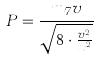Convert formula to latex. <formula><loc_0><loc_0><loc_500><loc_500>P = \frac { m _ { 7 } v } { \sqrt { 8 \cdot \frac { v ^ { 2 } } { x ^ { 2 } } } }</formula> 